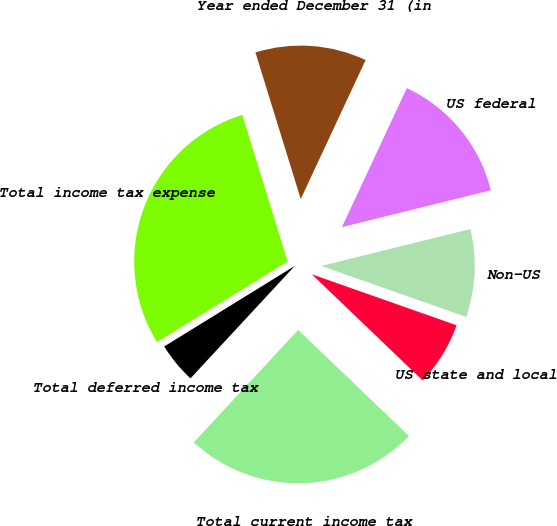Convert chart. <chart><loc_0><loc_0><loc_500><loc_500><pie_chart><fcel>Year ended December 31 (in<fcel>US federal<fcel>Non-US<fcel>US state and local<fcel>Total current income tax<fcel>Total deferred income tax<fcel>Total income tax expense<nl><fcel>11.72%<fcel>14.19%<fcel>9.25%<fcel>6.77%<fcel>24.74%<fcel>4.3%<fcel>29.03%<nl></chart> 